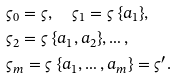Convert formula to latex. <formula><loc_0><loc_0><loc_500><loc_500>& \varsigma _ { 0 } = \varsigma , \quad \varsigma _ { 1 } = \varsigma \ \{ a _ { 1 } \} , \\ & \varsigma _ { 2 } = \varsigma \ \{ a _ { 1 } , a _ { 2 } \} , \dots , \\ & \varsigma _ { m } = \varsigma \ \{ a _ { 1 } , \dots , a _ { m } \} = \varsigma ^ { \prime } .</formula> 